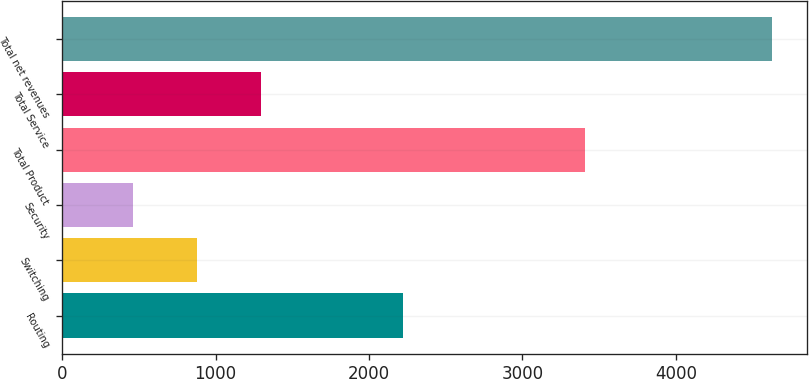<chart> <loc_0><loc_0><loc_500><loc_500><bar_chart><fcel>Routing<fcel>Switching<fcel>Security<fcel>Total Product<fcel>Total Service<fcel>Total net revenues<nl><fcel>2223.9<fcel>879.95<fcel>463.6<fcel>3408.7<fcel>1296.3<fcel>4627.1<nl></chart> 